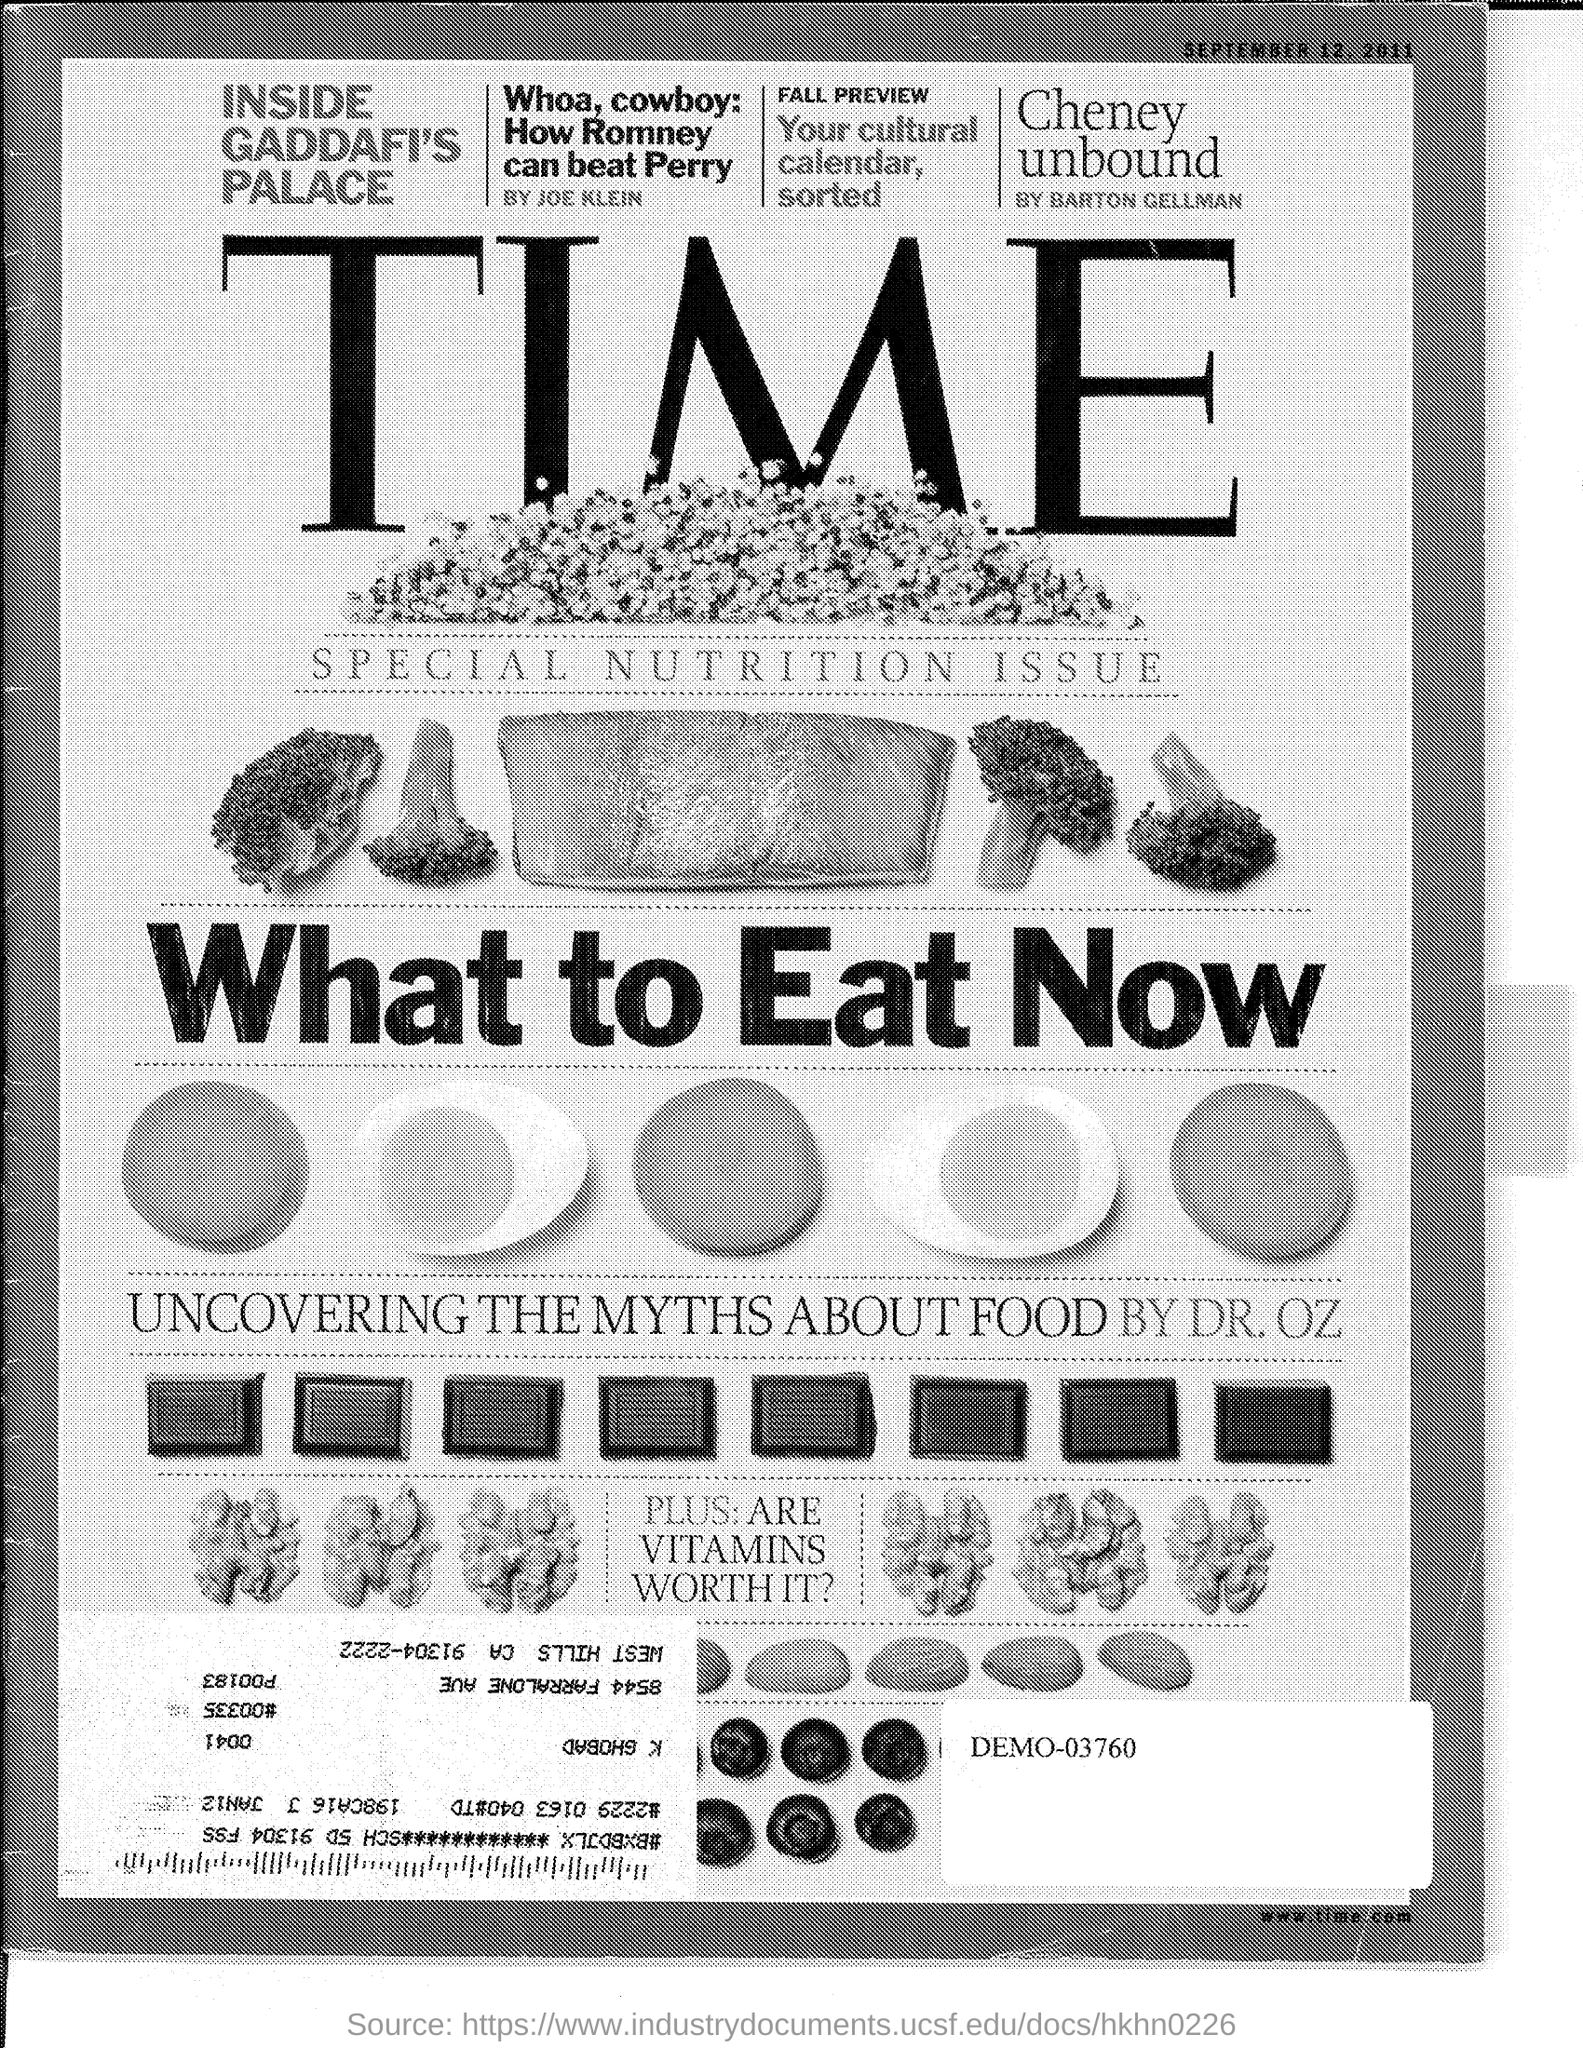Who wrote the article uncovering the myths about food?
Offer a very short reply. Dr. Oz. What is the date given on the top right of the page?
Your response must be concise. September 12, 2011. Name the article written by Joe Klein?
Give a very brief answer. Whoa, cowboy: How Romney can beat Perry. What is the demo number mentioned?
Keep it short and to the point. 03760. What is the website mentioned at right bottom?
Your answer should be compact. Www.time.com. 